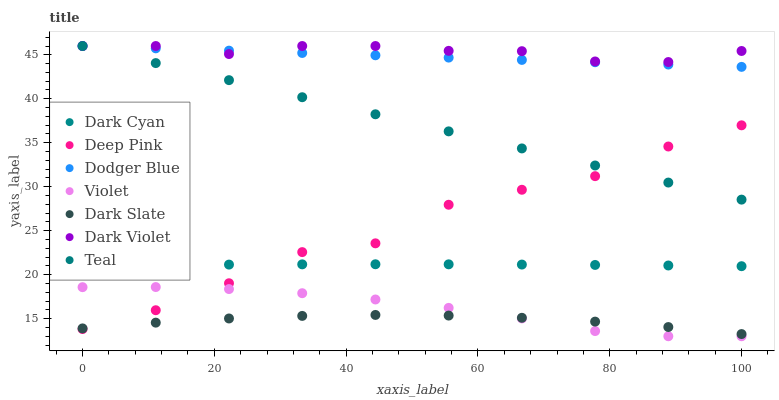Does Dark Slate have the minimum area under the curve?
Answer yes or no. Yes. Does Dark Violet have the maximum area under the curve?
Answer yes or no. Yes. Does Dark Violet have the minimum area under the curve?
Answer yes or no. No. Does Dark Slate have the maximum area under the curve?
Answer yes or no. No. Is Dodger Blue the smoothest?
Answer yes or no. Yes. Is Deep Pink the roughest?
Answer yes or no. Yes. Is Dark Violet the smoothest?
Answer yes or no. No. Is Dark Violet the roughest?
Answer yes or no. No. Does Violet have the lowest value?
Answer yes or no. Yes. Does Dark Slate have the lowest value?
Answer yes or no. No. Does Teal have the highest value?
Answer yes or no. Yes. Does Dark Slate have the highest value?
Answer yes or no. No. Is Dark Slate less than Teal?
Answer yes or no. Yes. Is Dodger Blue greater than Dark Slate?
Answer yes or no. Yes. Does Deep Pink intersect Teal?
Answer yes or no. Yes. Is Deep Pink less than Teal?
Answer yes or no. No. Is Deep Pink greater than Teal?
Answer yes or no. No. Does Dark Slate intersect Teal?
Answer yes or no. No. 